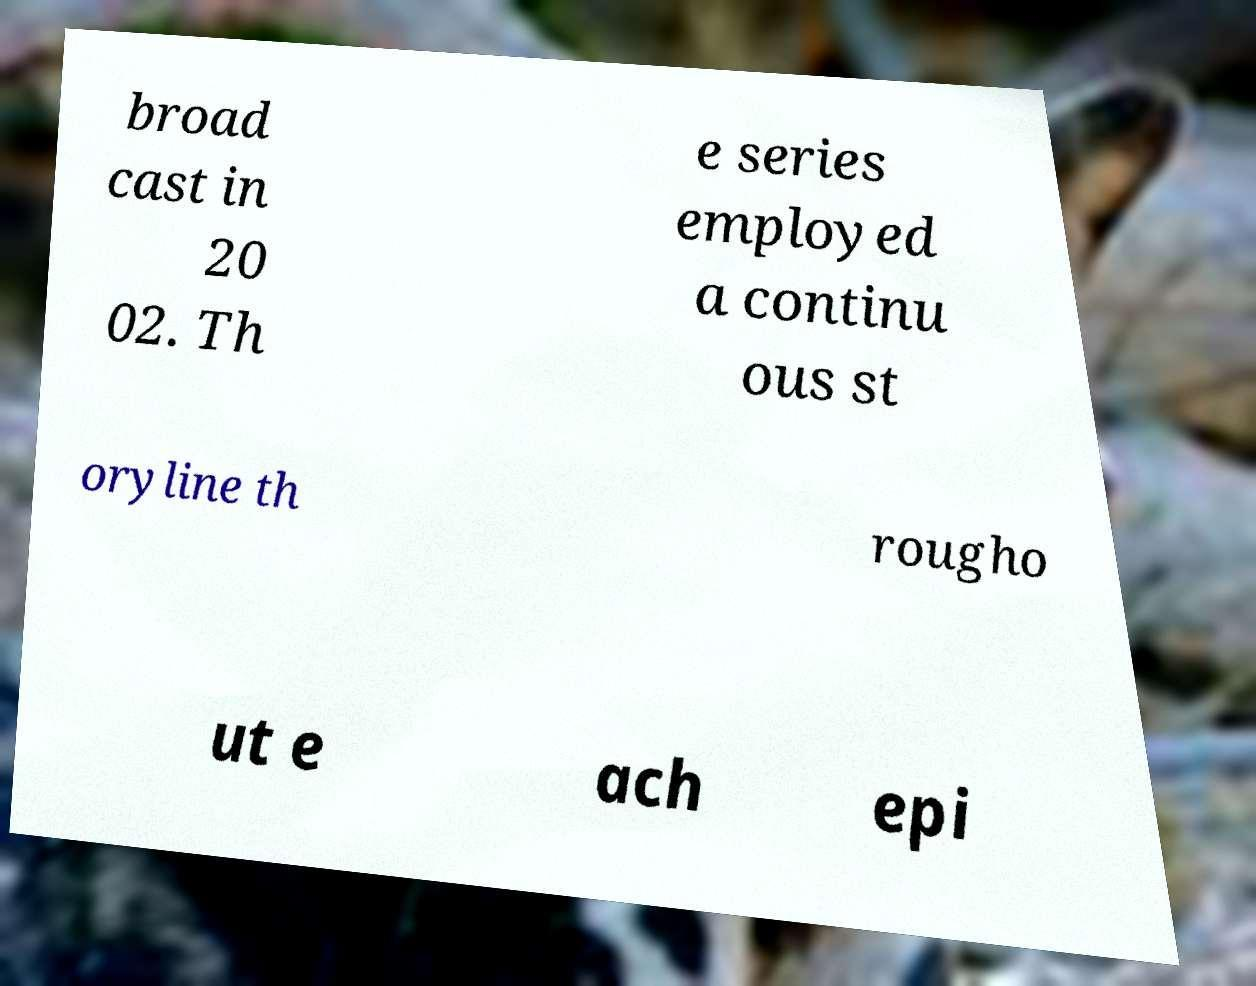Could you extract and type out the text from this image? broad cast in 20 02. Th e series employed a continu ous st oryline th rougho ut e ach epi 